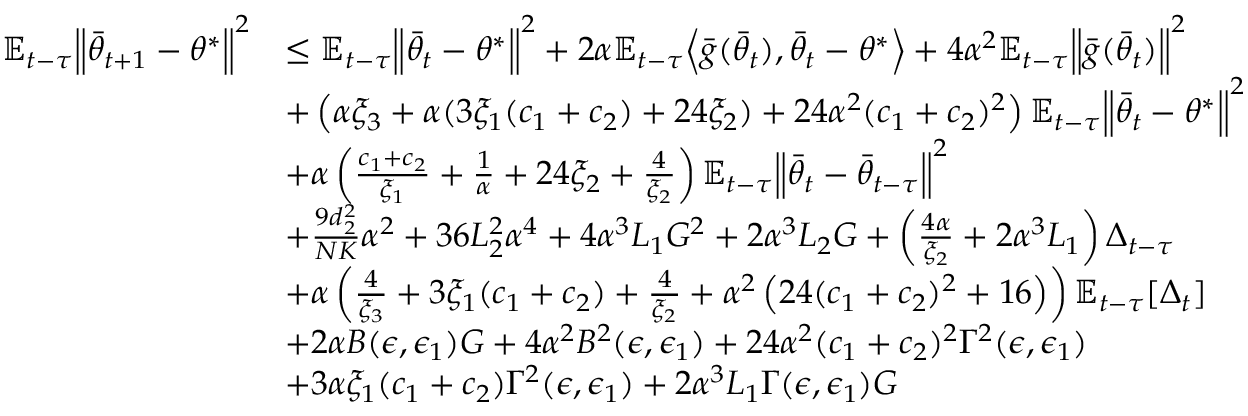<formula> <loc_0><loc_0><loc_500><loc_500>\begin{array} { r l } { \mathbb { E } _ { t - \tau } \left \| \bar { \theta } _ { t + 1 } - \theta ^ { * } \right \| ^ { 2 } } & { \leq \mathbb { E } _ { t - \tau } \left \| \bar { \theta } _ { t } - \theta ^ { * } \right \| ^ { 2 } + 2 \alpha \mathbb { E } _ { t - \tau } \left \langle \bar { g } ( \bar { \theta } _ { t } ) , \bar { \theta } _ { t } - \theta ^ { * } \right \rangle + 4 \alpha ^ { 2 } \mathbb { E } _ { t - \tau } \left \| \bar { g } ( \bar { \theta } _ { t } ) \right \| ^ { 2 } } \\ & { + \left ( \alpha \xi _ { 3 } + \alpha ( 3 \xi _ { 1 } ( c _ { 1 } + c _ { 2 } ) + 2 4 \xi _ { 2 } ) + 2 4 \alpha ^ { 2 } ( c _ { 1 } + c _ { 2 } ) ^ { 2 } \right ) \mathbb { E } _ { t - \tau } \left \| \bar { \theta } _ { t } - \theta ^ { * } \right \| ^ { 2 } } \\ & { + \alpha \left ( \frac { c _ { 1 } + c _ { 2 } } { \xi _ { 1 } } + \frac { 1 } { \alpha } + 2 4 \xi _ { 2 } + \frac { 4 } { \xi _ { 2 } } \right ) \mathbb { E } _ { t - \tau } \left \| \bar { \theta } _ { t } - \bar { \theta } _ { t - \tau } \right \| ^ { 2 } } \\ & { + \frac { 9 d _ { 2 } ^ { 2 } } { N K } \alpha ^ { 2 } + 3 6 L _ { 2 } ^ { 2 } \alpha ^ { 4 } + 4 \alpha ^ { 3 } L _ { 1 } G ^ { 2 } + 2 \alpha ^ { 3 } L _ { 2 } G + \left ( \frac { 4 \alpha } { \xi _ { 2 } } + 2 \alpha ^ { 3 } L _ { 1 } \right ) \Delta _ { t - \tau } } \\ & { + \alpha \left ( \frac { 4 } { \xi _ { 3 } } + 3 \xi _ { 1 } ( c _ { 1 } + c _ { 2 } ) + \frac { 4 } { \xi _ { 2 } } + \alpha ^ { 2 } \left ( 2 4 ( c _ { 1 } + c _ { 2 } ) ^ { 2 } + 1 6 \right ) \right ) \mathbb { E } _ { t - \tau } [ \Delta _ { t } ] } \\ & { + 2 \alpha B ( \epsilon , \epsilon _ { 1 } ) G + 4 \alpha ^ { 2 } B ^ { 2 } ( \epsilon , \epsilon _ { 1 } ) + 2 4 \alpha ^ { 2 } ( c _ { 1 } + c _ { 2 } ) ^ { 2 } \Gamma ^ { 2 } ( \epsilon , \epsilon _ { 1 } ) } \\ & { + 3 \alpha \xi _ { 1 } ( c _ { 1 } + c _ { 2 } ) \Gamma ^ { 2 } ( \epsilon , \epsilon _ { 1 } ) + 2 \alpha ^ { 3 } L _ { 1 } \Gamma ( \epsilon , \epsilon _ { 1 } ) G } \end{array}</formula> 